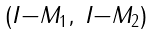<formula> <loc_0><loc_0><loc_500><loc_500>\begin{smallmatrix} ( I - M _ { 1 } , & I - M _ { 2 } ) \end{smallmatrix}</formula> 